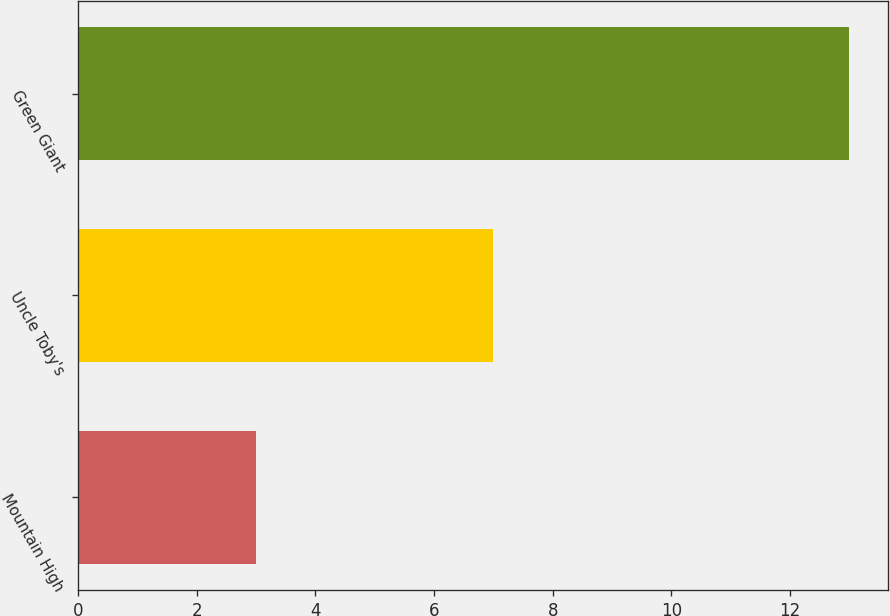Convert chart to OTSL. <chart><loc_0><loc_0><loc_500><loc_500><bar_chart><fcel>Mountain High<fcel>Uncle Toby's<fcel>Green Giant<nl><fcel>3<fcel>7<fcel>13<nl></chart> 